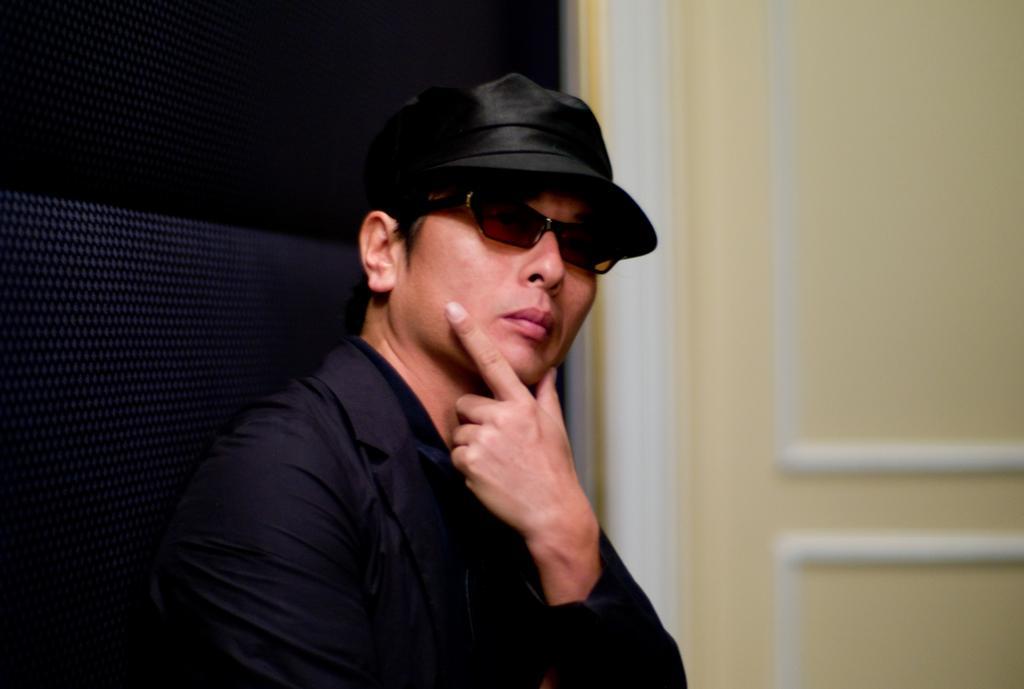In one or two sentences, can you explain what this image depicts? In this picture I can observe a man. He is wearing black color coat, spectacles and a cap on his head. On the right side I can observe cream color wall. 